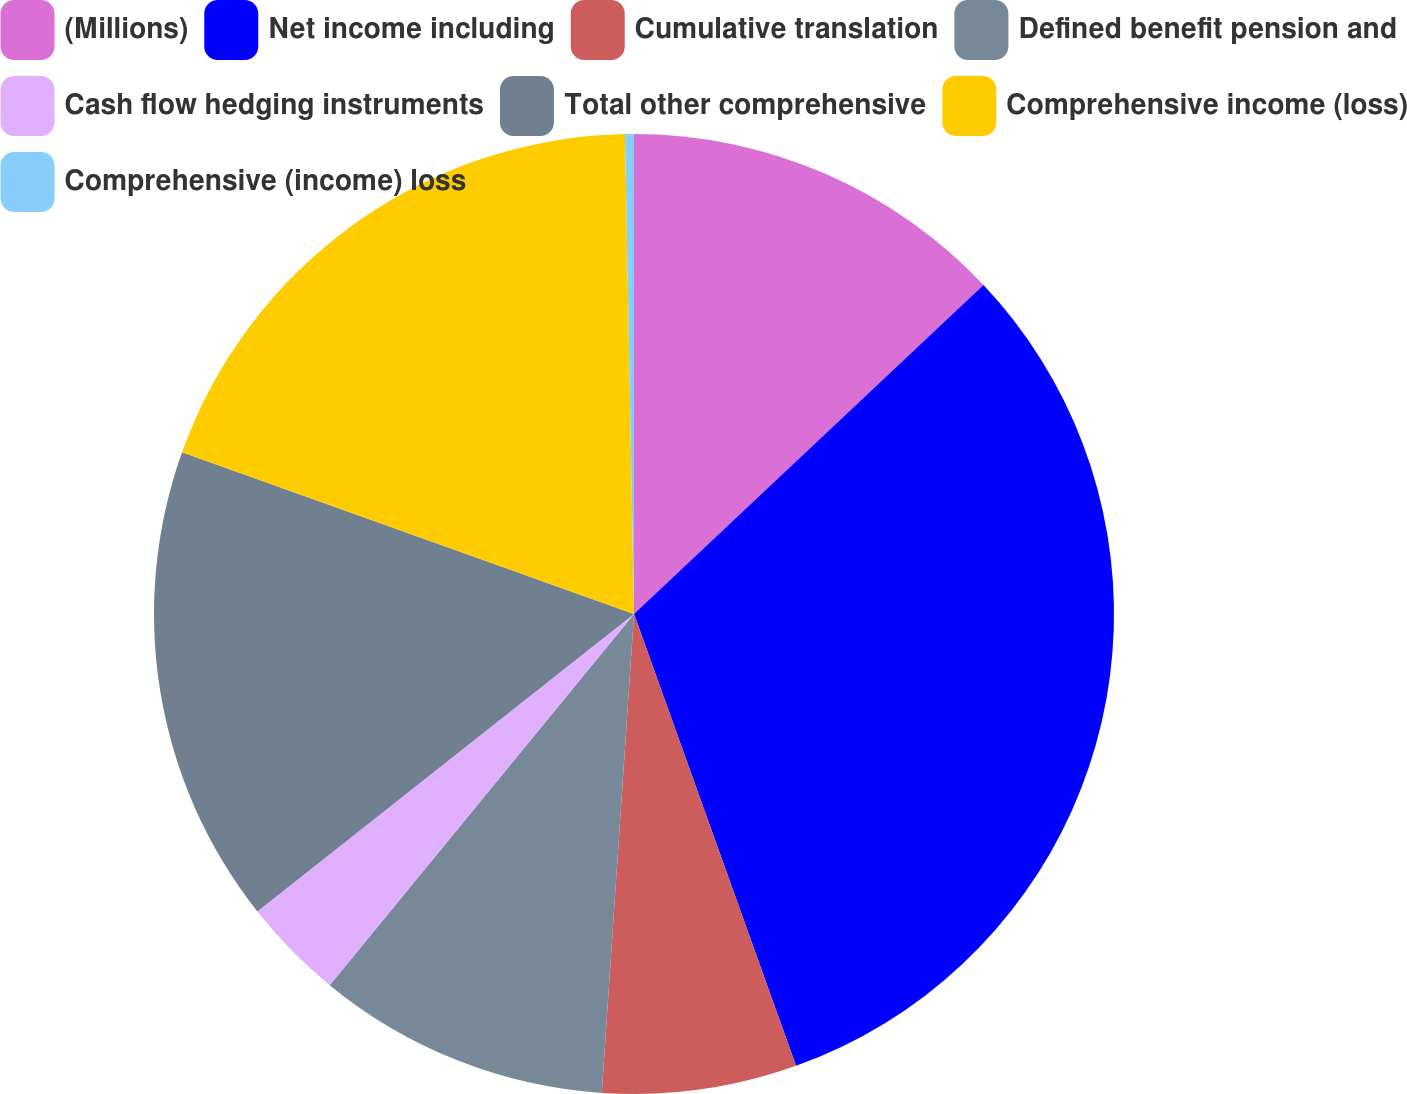Convert chart. <chart><loc_0><loc_0><loc_500><loc_500><pie_chart><fcel>(Millions)<fcel>Net income including<fcel>Cumulative translation<fcel>Defined benefit pension and<fcel>Cash flow hedging instruments<fcel>Total other comprehensive<fcel>Comprehensive income (loss)<fcel>Comprehensive (income) loss<nl><fcel>12.98%<fcel>31.54%<fcel>6.55%<fcel>9.86%<fcel>3.43%<fcel>16.11%<fcel>19.23%<fcel>0.3%<nl></chart> 